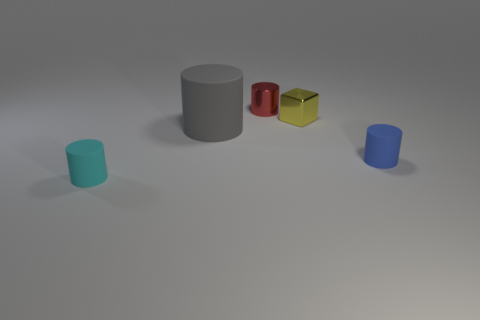Is the tiny cylinder to the left of the red cylinder made of the same material as the tiny cylinder behind the yellow cube?
Offer a terse response. No. Does the object in front of the tiny blue object have the same material as the tiny red cylinder?
Make the answer very short. No. The cylinder that is both right of the large cylinder and behind the blue thing is what color?
Offer a very short reply. Red. What is the size of the gray rubber thing that is in front of the shiny thing that is left of the yellow block?
Your answer should be very brief. Large. How many balls are gray objects or large yellow objects?
Provide a succinct answer. 0. There is a cube that is the same size as the red object; what is its color?
Provide a succinct answer. Yellow. There is a matte thing that is behind the rubber object that is to the right of the red cylinder; what is its shape?
Ensure brevity in your answer.  Cylinder. Is the size of the metal thing to the right of the red cylinder the same as the tiny blue cylinder?
Provide a succinct answer. Yes. How many other things are there of the same material as the large gray cylinder?
Ensure brevity in your answer.  2. What number of gray objects are small metal spheres or big rubber cylinders?
Your answer should be very brief. 1. 